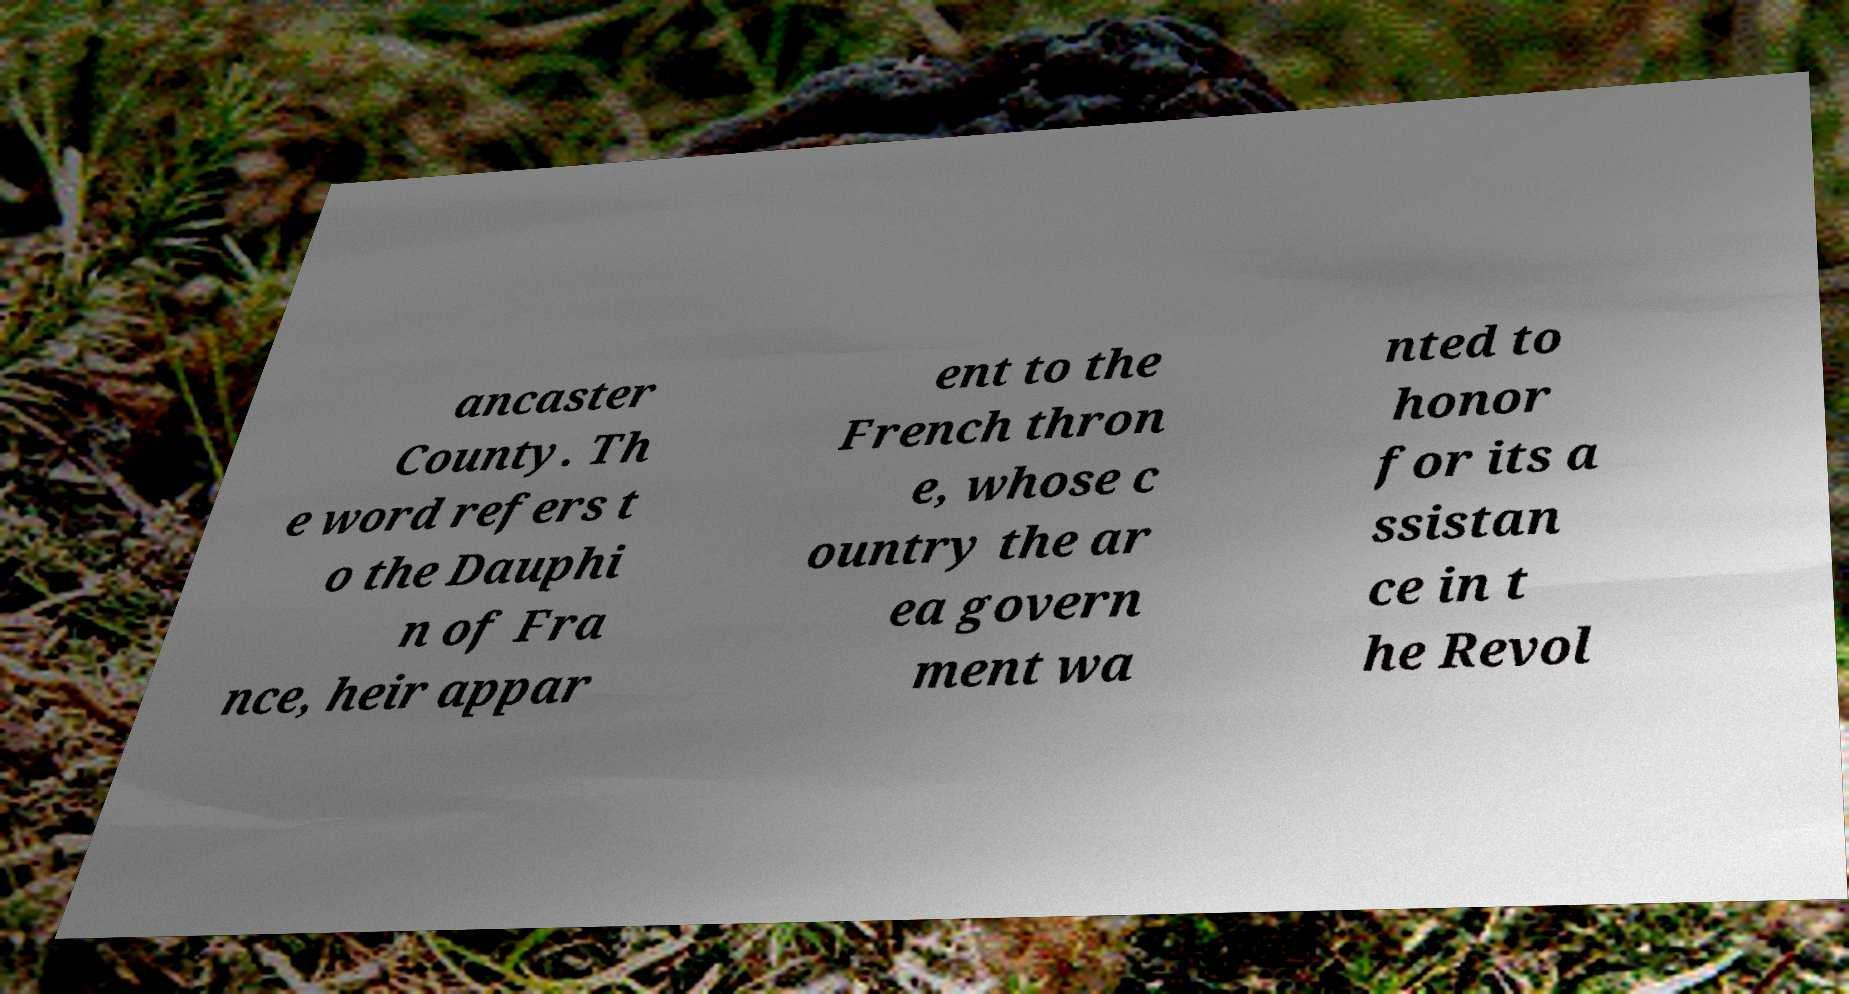For documentation purposes, I need the text within this image transcribed. Could you provide that? ancaster County. Th e word refers t o the Dauphi n of Fra nce, heir appar ent to the French thron e, whose c ountry the ar ea govern ment wa nted to honor for its a ssistan ce in t he Revol 